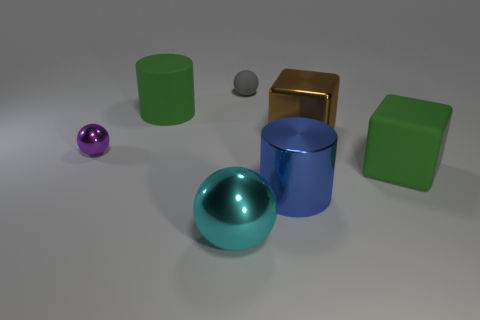Add 2 large cyan balls. How many objects exist? 9 Subtract all small gray rubber balls. How many balls are left? 2 Add 7 large cyan metallic things. How many large cyan metallic things exist? 8 Subtract all gray spheres. How many spheres are left? 2 Subtract 0 red spheres. How many objects are left? 7 Subtract all cylinders. How many objects are left? 5 Subtract 1 cubes. How many cubes are left? 1 Subtract all blue spheres. Subtract all red cubes. How many spheres are left? 3 Subtract all yellow cylinders. How many purple spheres are left? 1 Subtract all big cyan shiny cylinders. Subtract all big matte things. How many objects are left? 5 